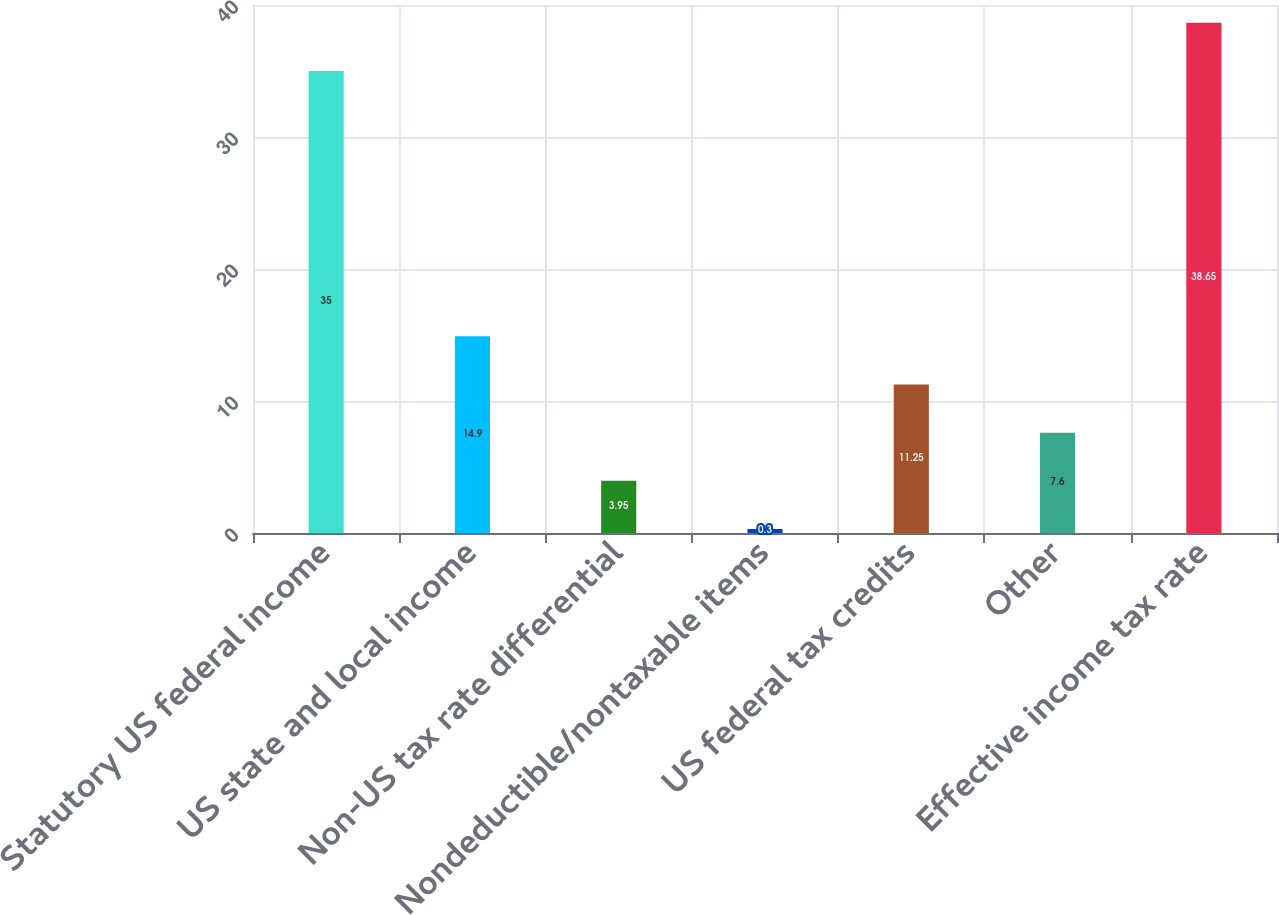<chart> <loc_0><loc_0><loc_500><loc_500><bar_chart><fcel>Statutory US federal income<fcel>US state and local income<fcel>Non-US tax rate differential<fcel>Nondeductible/nontaxable items<fcel>US federal tax credits<fcel>Other<fcel>Effective income tax rate<nl><fcel>35<fcel>14.9<fcel>3.95<fcel>0.3<fcel>11.25<fcel>7.6<fcel>38.65<nl></chart> 